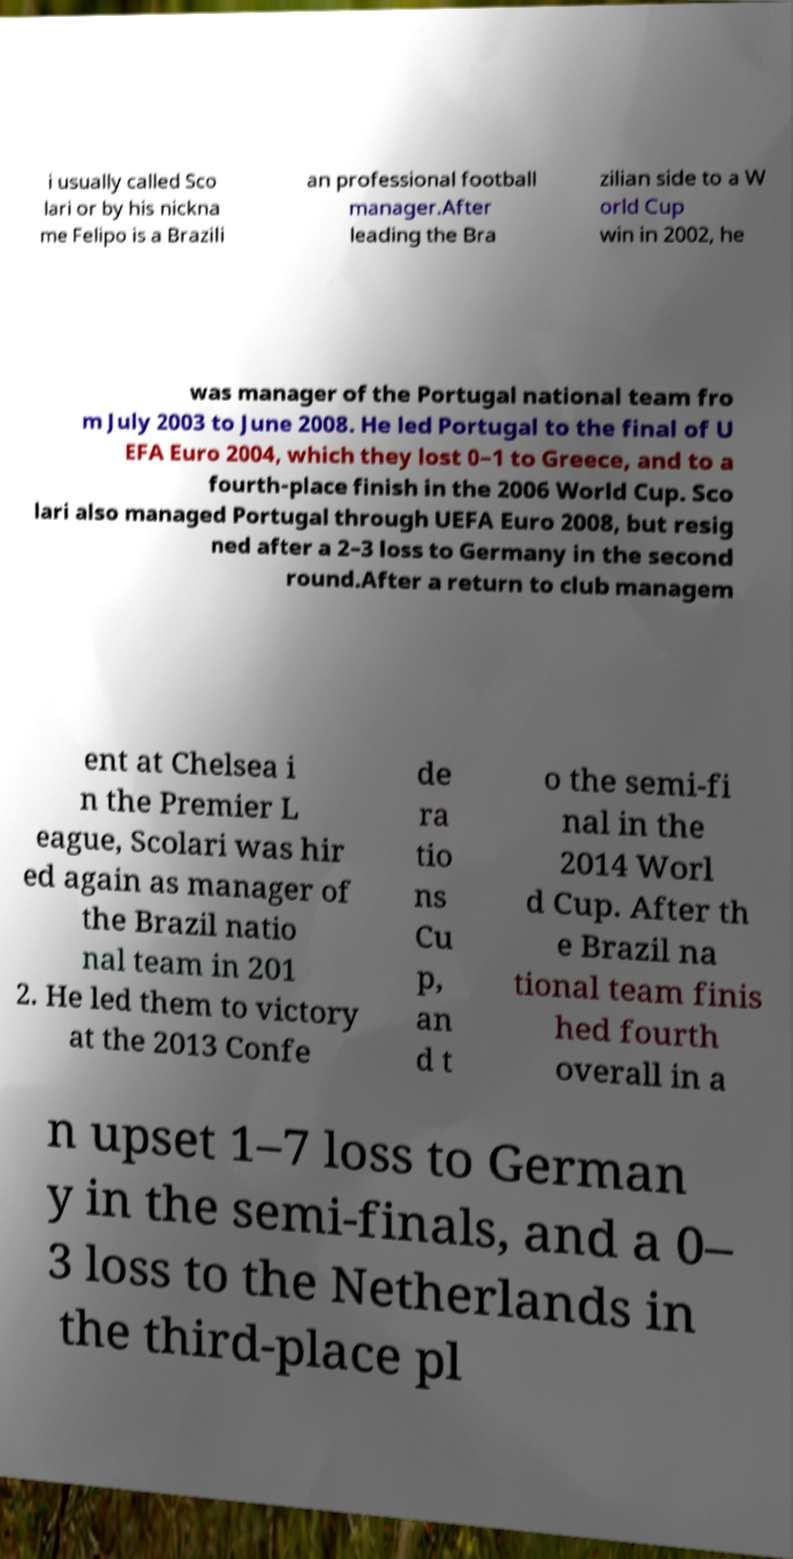I need the written content from this picture converted into text. Can you do that? i usually called Sco lari or by his nickna me Felipo is a Brazili an professional football manager.After leading the Bra zilian side to a W orld Cup win in 2002, he was manager of the Portugal national team fro m July 2003 to June 2008. He led Portugal to the final of U EFA Euro 2004, which they lost 0–1 to Greece, and to a fourth-place finish in the 2006 World Cup. Sco lari also managed Portugal through UEFA Euro 2008, but resig ned after a 2–3 loss to Germany in the second round.After a return to club managem ent at Chelsea i n the Premier L eague, Scolari was hir ed again as manager of the Brazil natio nal team in 201 2. He led them to victory at the 2013 Confe de ra tio ns Cu p, an d t o the semi-fi nal in the 2014 Worl d Cup. After th e Brazil na tional team finis hed fourth overall in a n upset 1–7 loss to German y in the semi-finals, and a 0– 3 loss to the Netherlands in the third-place pl 